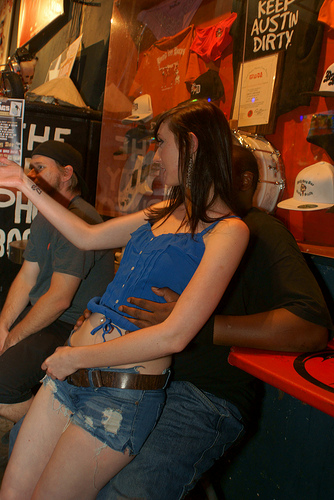<image>
Is the girl next to the man? Yes. The girl is positioned adjacent to the man, located nearby in the same general area. 